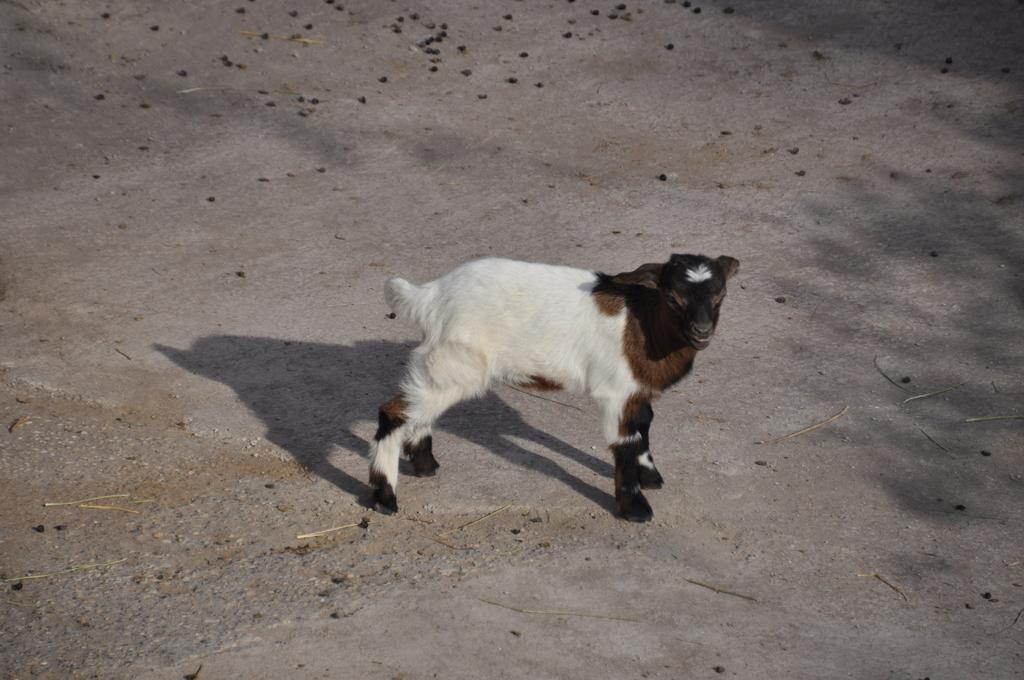How would you summarize this image in a sentence or two? In the center of the image we can see a goat on the ground. 